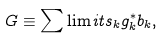Convert formula to latex. <formula><loc_0><loc_0><loc_500><loc_500>G \equiv \sum \lim i t s _ { k } g _ { k } ^ { * } b _ { k } ,</formula> 